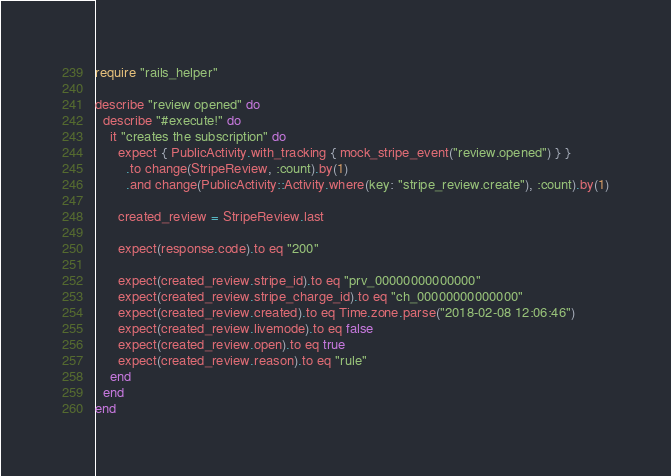Convert code to text. <code><loc_0><loc_0><loc_500><loc_500><_Ruby_>require "rails_helper"

describe "review opened" do
  describe "#execute!" do
    it "creates the subscription" do
      expect { PublicActivity.with_tracking { mock_stripe_event("review.opened") } }
        .to change(StripeReview, :count).by(1)
        .and change(PublicActivity::Activity.where(key: "stripe_review.create"), :count).by(1)

      created_review = StripeReview.last

      expect(response.code).to eq "200"

      expect(created_review.stripe_id).to eq "prv_00000000000000"
      expect(created_review.stripe_charge_id).to eq "ch_00000000000000"
      expect(created_review.created).to eq Time.zone.parse("2018-02-08 12:06:46")
      expect(created_review.livemode).to eq false
      expect(created_review.open).to eq true
      expect(created_review.reason).to eq "rule"
    end
  end
end
</code> 